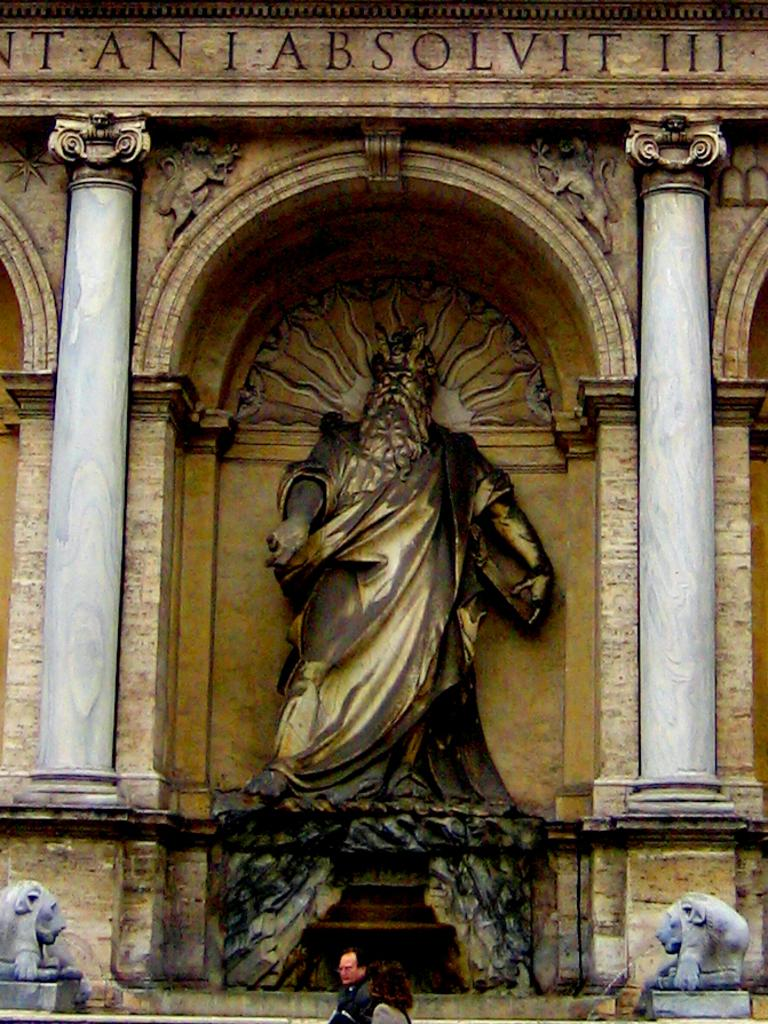Who or what is present in the image? There are people in the image. What are the people doing in the image? The people are walking. What is the main structure in the image? There is a big monument in the image. Can you describe the monument's features? The monument has pillars, and there are statues on either side by side on either side of the monument. What type of arithmetic problem can be solved using the statues on the monument? There is no arithmetic problem present in the image, as it features people walking and a monument with statues. What is the butter used for in the image? There is no butter present in the image. 